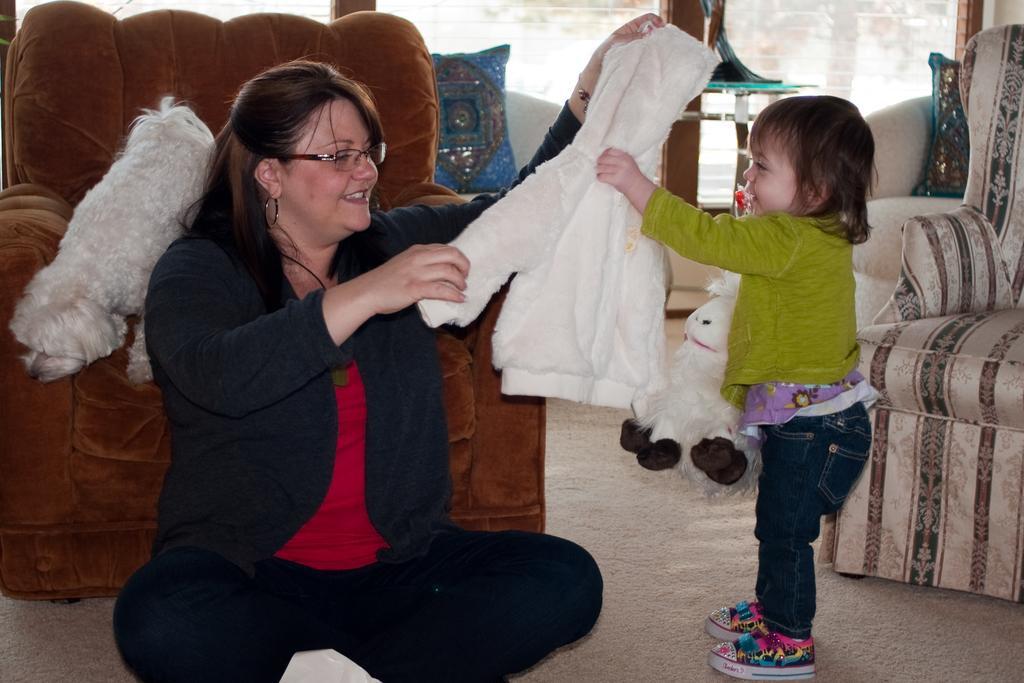Please provide a concise description of this image. Woman is sitting on the floor and folding the clothes a baby is standing , holding a sweater behind them there is a sofa and a dog is standing on it. Right side of an image there is a window. 